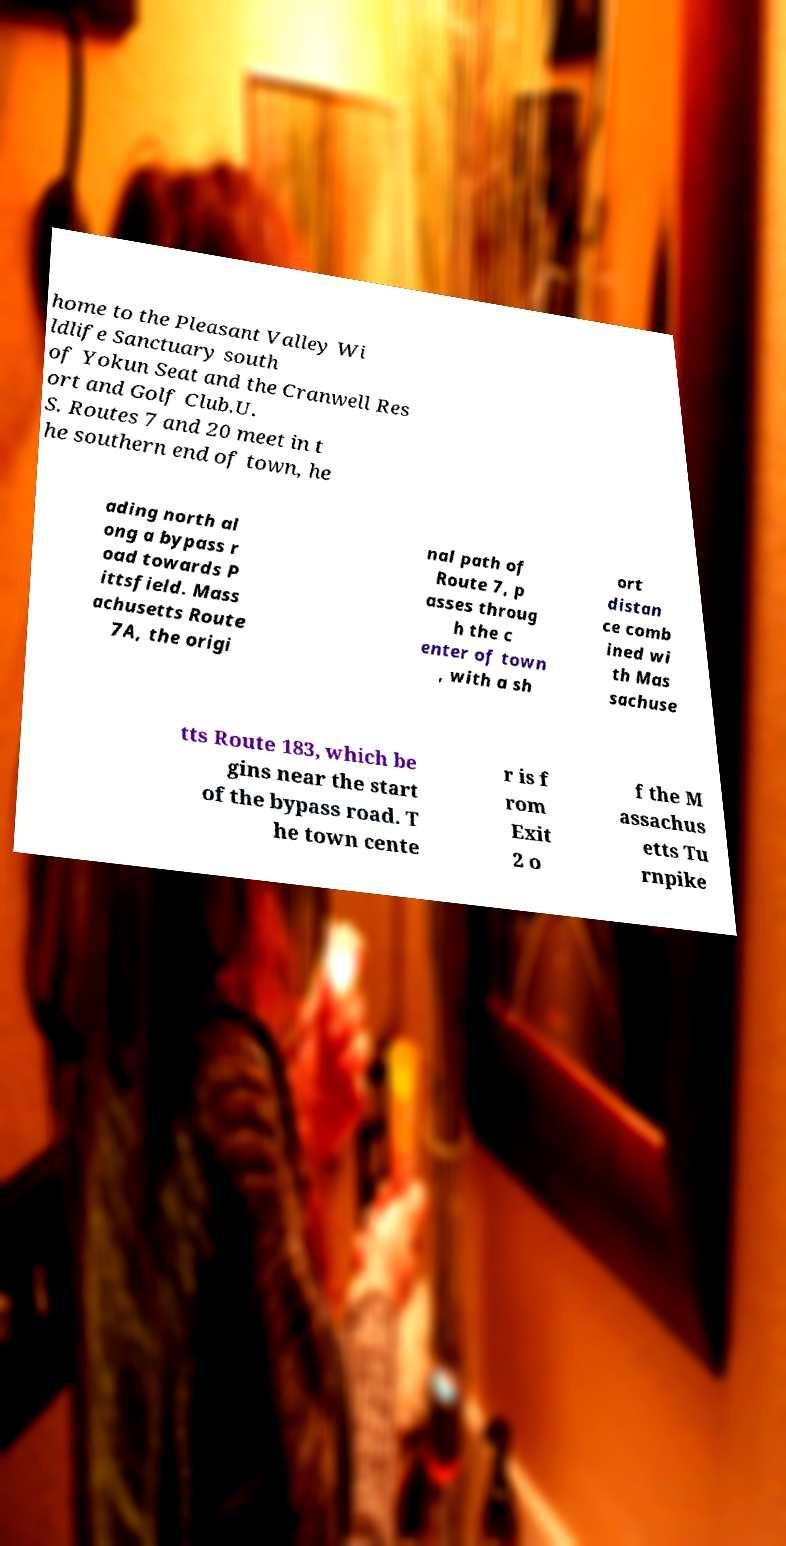Please identify and transcribe the text found in this image. home to the Pleasant Valley Wi ldlife Sanctuary south of Yokun Seat and the Cranwell Res ort and Golf Club.U. S. Routes 7 and 20 meet in t he southern end of town, he ading north al ong a bypass r oad towards P ittsfield. Mass achusetts Route 7A, the origi nal path of Route 7, p asses throug h the c enter of town , with a sh ort distan ce comb ined wi th Mas sachuse tts Route 183, which be gins near the start of the bypass road. T he town cente r is f rom Exit 2 o f the M assachus etts Tu rnpike 